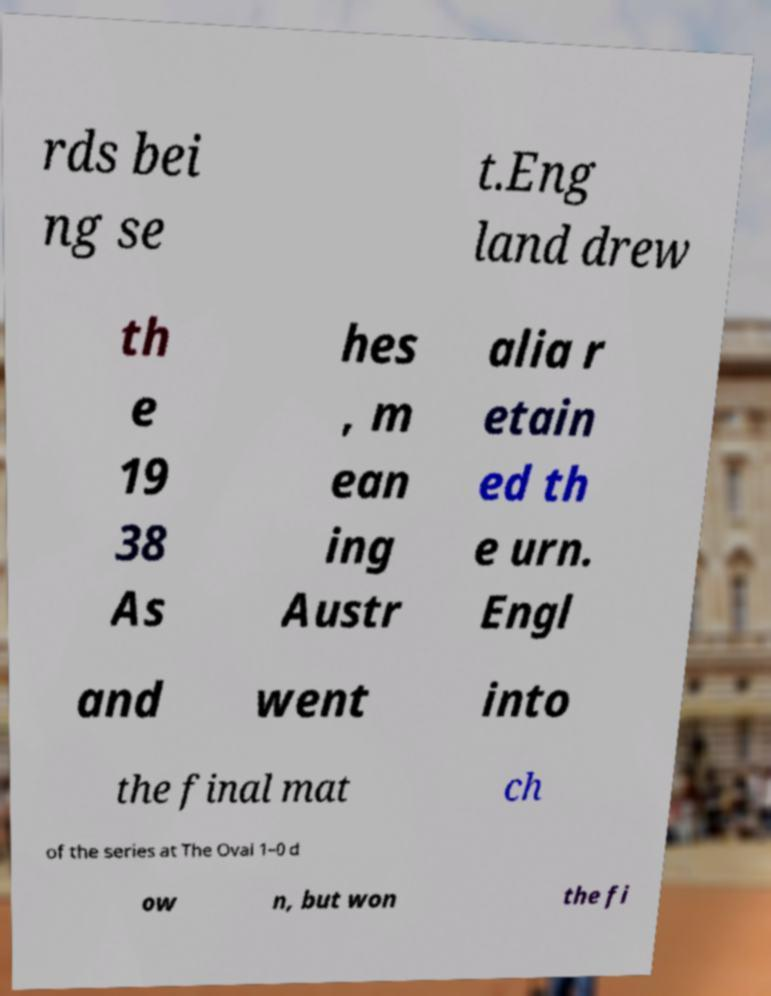Could you assist in decoding the text presented in this image and type it out clearly? rds bei ng se t.Eng land drew th e 19 38 As hes , m ean ing Austr alia r etain ed th e urn. Engl and went into the final mat ch of the series at The Oval 1–0 d ow n, but won the fi 